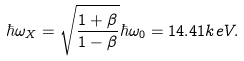Convert formula to latex. <formula><loc_0><loc_0><loc_500><loc_500>\hbar { \omega } _ { X } = \sqrt { \frac { 1 + \beta } { 1 - \beta } } \hbar { \omega } _ { 0 } = 1 4 . 4 1 k e V .</formula> 